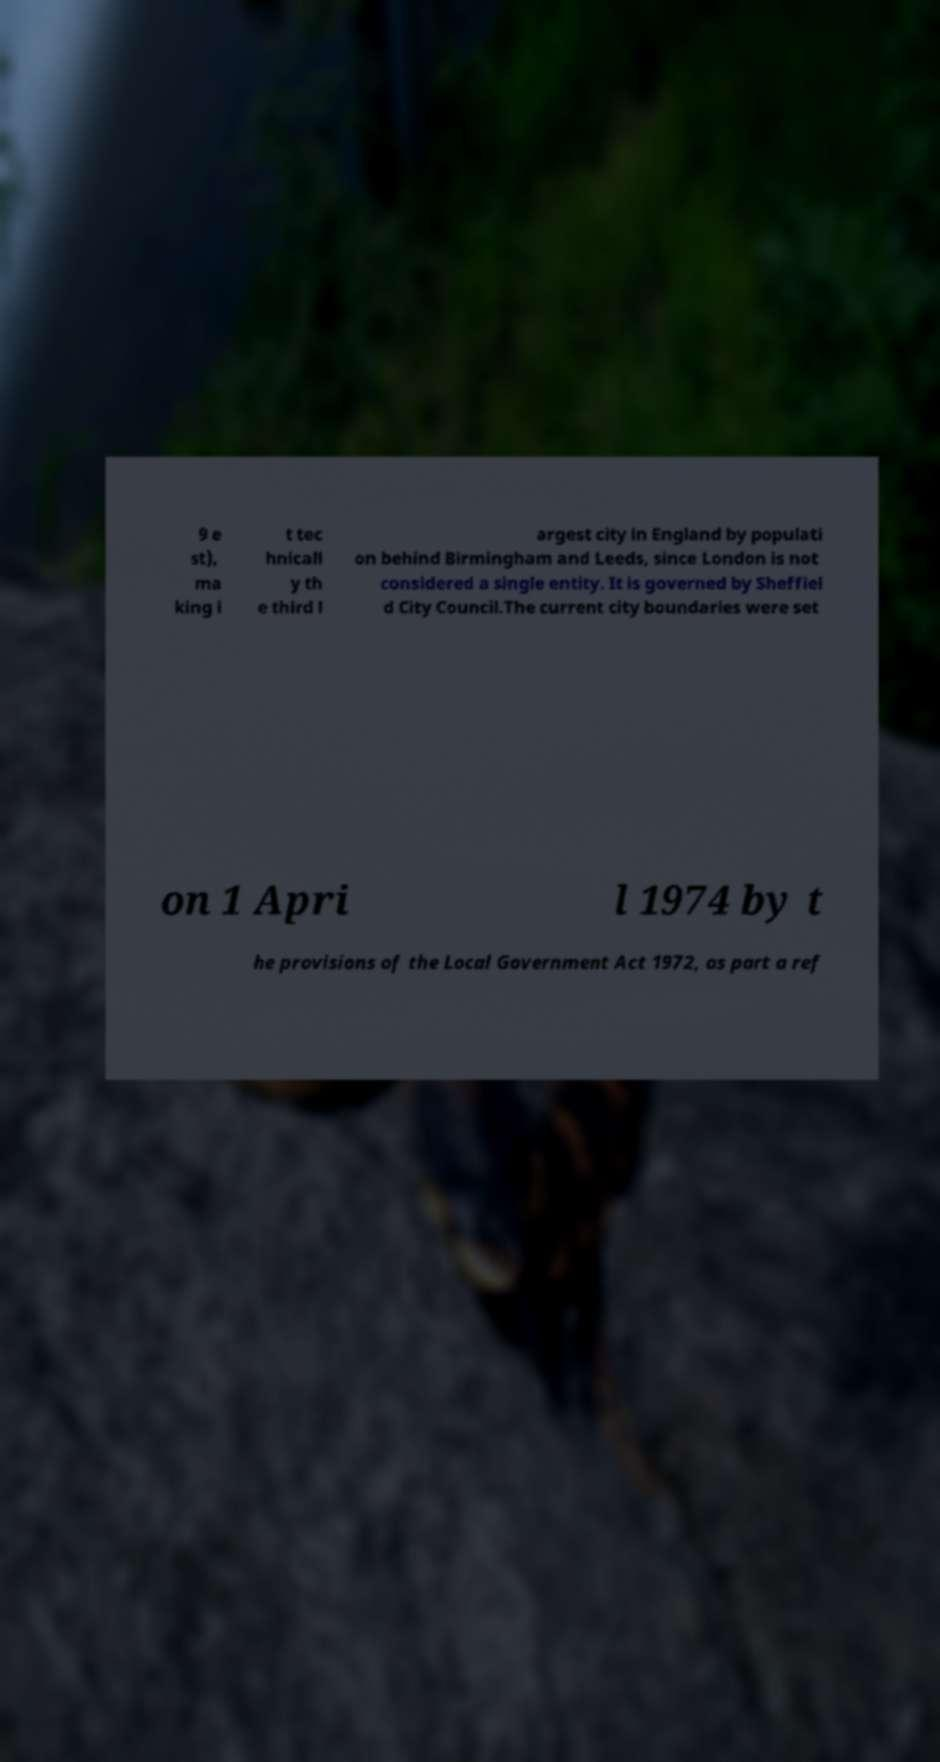Please read and relay the text visible in this image. What does it say? 9 e st), ma king i t tec hnicall y th e third l argest city in England by populati on behind Birmingham and Leeds, since London is not considered a single entity. It is governed by Sheffiel d City Council.The current city boundaries were set on 1 Apri l 1974 by t he provisions of the Local Government Act 1972, as part a ref 